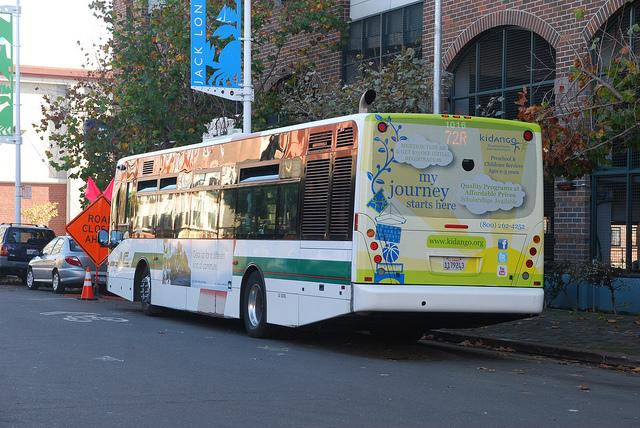What word is on the orange sign?

Choices:
A) road
B) leave
C) stop
D) beware road 